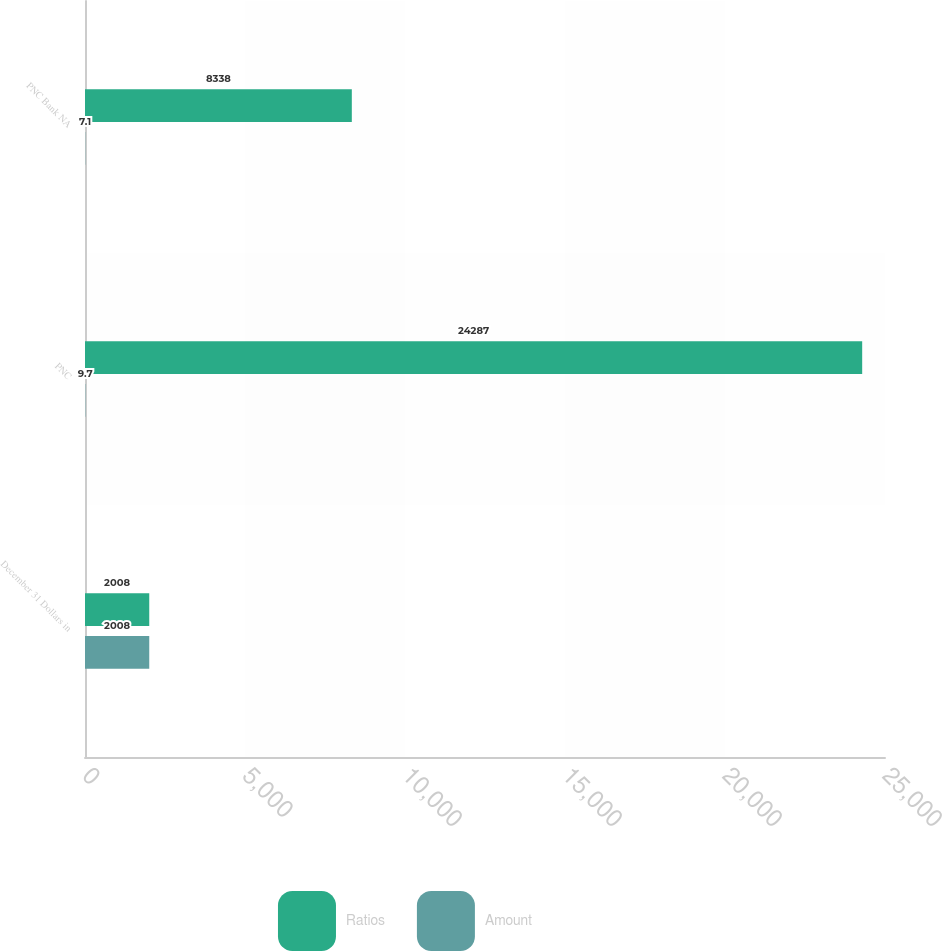Convert chart. <chart><loc_0><loc_0><loc_500><loc_500><stacked_bar_chart><ecel><fcel>December 31 Dollars in<fcel>PNC<fcel>PNC Bank NA<nl><fcel>Ratios<fcel>2008<fcel>24287<fcel>8338<nl><fcel>Amount<fcel>2008<fcel>9.7<fcel>7.1<nl></chart> 